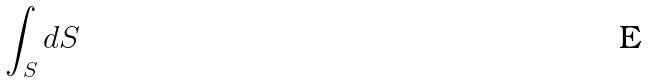<formula> <loc_0><loc_0><loc_500><loc_500>\int _ { S } d S</formula> 